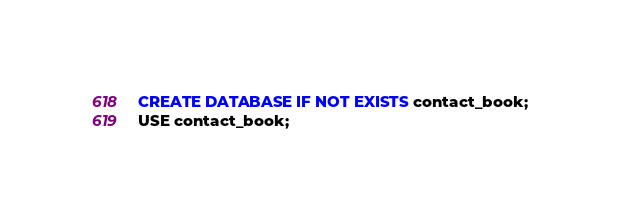<code> <loc_0><loc_0><loc_500><loc_500><_SQL_>CREATE DATABASE IF NOT EXISTS contact_book;
USE contact_book;
</code> 